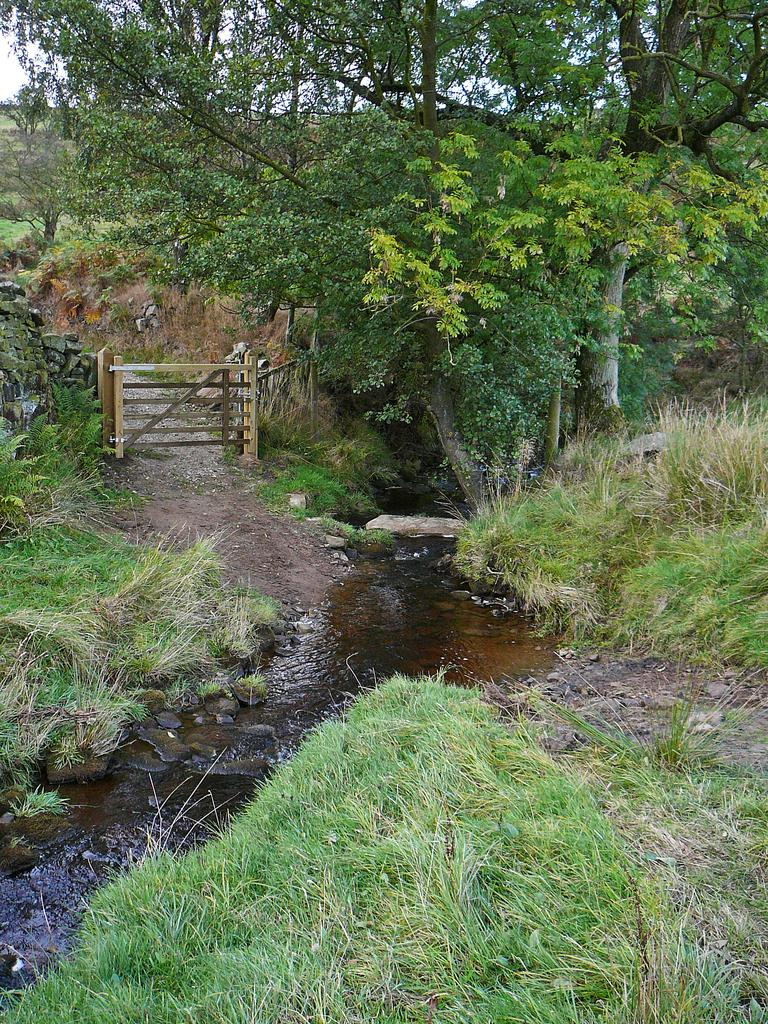What type of natural environment is depicted in the image? There is greenery in the image, suggesting a natural environment. What is the water doing in the image? Water is flowing in between the grass surface in the image. What can be seen on the left side of the image? There is a wooden fence on the left side of the image. What scent is associated with the sock in the image? There is no sock present in the image, so it is not possible to determine any associated scent. 